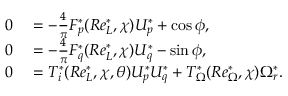<formula> <loc_0><loc_0><loc_500><loc_500>\begin{array} { r l } { 0 } & = - \frac { 4 } { \pi } F _ { p } ^ { * } ( R e _ { L } ^ { * } , \chi ) U _ { p } ^ { * } + \cos \phi , } \\ { 0 } & = - \frac { 4 } { \pi } F _ { q } ^ { * } ( R e _ { L } ^ { * } , \chi ) U _ { q } ^ { * } - \sin \phi , } \\ { 0 } & = T _ { i } ^ { * } ( R e _ { L } ^ { * } , \chi , \theta ) U _ { p } ^ { * } U _ { q } ^ { * } + T _ { \Omega } ^ { * } ( R e _ { \Omega } ^ { * } , \chi ) \Omega _ { r } ^ { * } . } \end{array}</formula> 